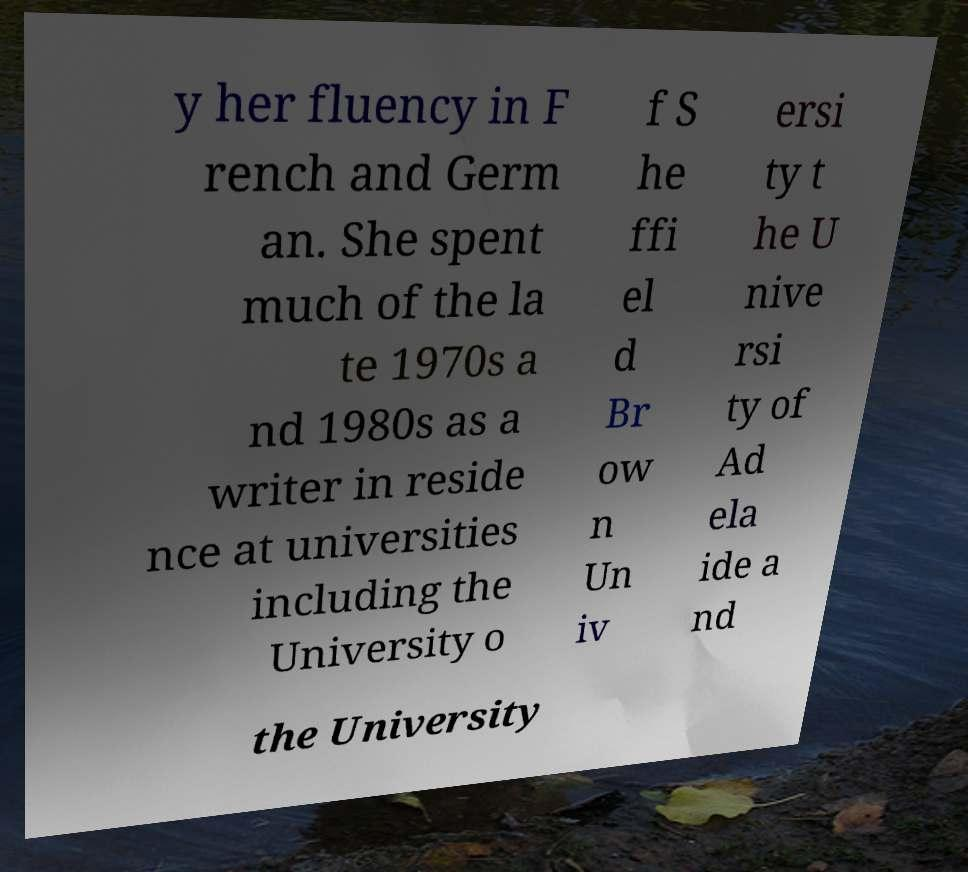Can you read and provide the text displayed in the image?This photo seems to have some interesting text. Can you extract and type it out for me? y her fluency in F rench and Germ an. She spent much of the la te 1970s a nd 1980s as a writer in reside nce at universities including the University o f S he ffi el d Br ow n Un iv ersi ty t he U nive rsi ty of Ad ela ide a nd the University 